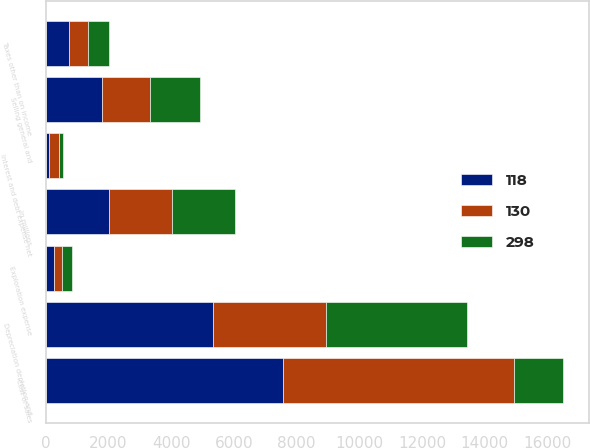Convert chart. <chart><loc_0><loc_0><loc_500><loc_500><stacked_bar_chart><ecel><fcel>In millions<fcel>Cost of sales<fcel>Selling general and<fcel>Depreciation depletion and<fcel>Taxes other than on income<fcel>Exploration expense<fcel>Interest and debt expense net<nl><fcel>118<fcel>2013<fcel>7562<fcel>1801<fcel>5347<fcel>749<fcel>256<fcel>118<nl><fcel>298<fcel>2012<fcel>1562.5<fcel>1602<fcel>4511<fcel>680<fcel>345<fcel>130<nl><fcel>130<fcel>2011<fcel>7385<fcel>1523<fcel>3591<fcel>605<fcel>258<fcel>298<nl></chart> 